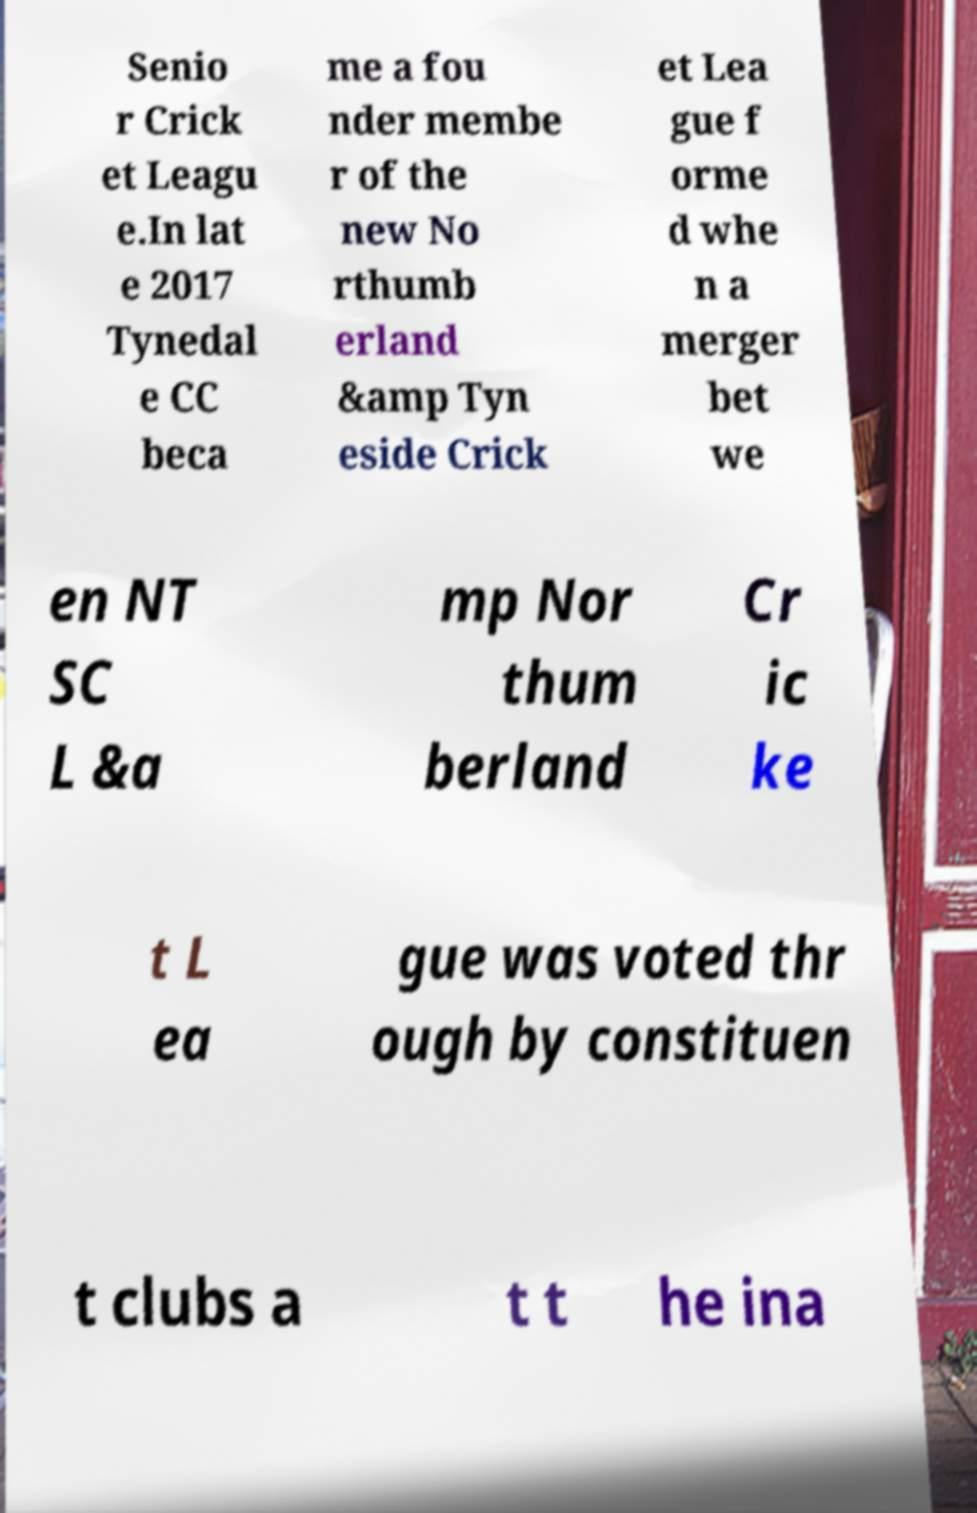For documentation purposes, I need the text within this image transcribed. Could you provide that? Senio r Crick et Leagu e.In lat e 2017 Tynedal e CC beca me a fou nder membe r of the new No rthumb erland &amp Tyn eside Crick et Lea gue f orme d whe n a merger bet we en NT SC L &a mp Nor thum berland Cr ic ke t L ea gue was voted thr ough by constituen t clubs a t t he ina 